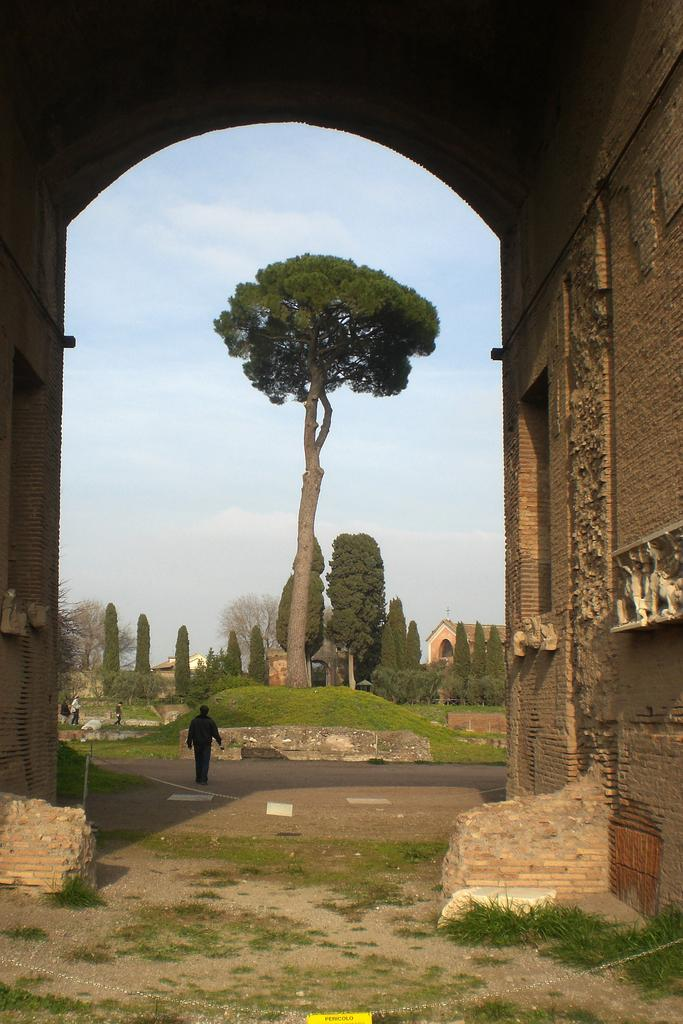What is the man in the image doing? The man is walking in the image. What type of natural elements can be seen in the image? There are trees visible in the image. What type of man-made structures can be seen in the image? There are buildings in the image. How would you describe the sky in the image? The sky is blue and cloudy in the image. What type of butter is being used to grease the pot in the image? There is no butter or pot present in the image; it only features a man walking, trees, buildings, and a blue and cloudy sky. 